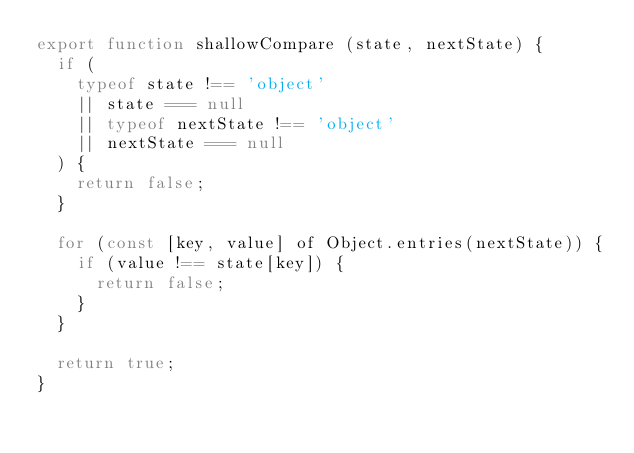<code> <loc_0><loc_0><loc_500><loc_500><_JavaScript_>export function shallowCompare (state, nextState) {
  if (
    typeof state !== 'object'
    || state === null
    || typeof nextState !== 'object'
    || nextState === null
  ) {
    return false;
  }

  for (const [key, value] of Object.entries(nextState)) {
    if (value !== state[key]) {
      return false;
    }
  }

  return true;
}</code> 